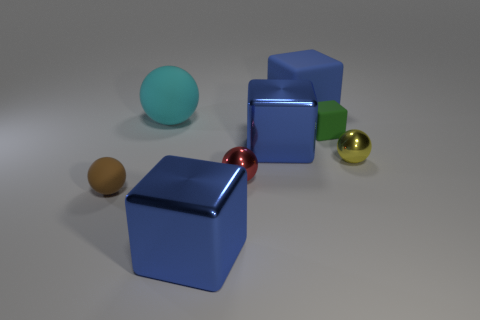How many objects are big things that are behind the tiny rubber sphere or brown spheres?
Offer a very short reply. 4. How many other objects are the same material as the green object?
Offer a terse response. 3. What size is the blue metal object behind the brown object?
Your response must be concise. Large. What shape is the small yellow thing that is the same material as the red thing?
Make the answer very short. Sphere. Does the yellow object have the same material as the big block behind the green thing?
Provide a succinct answer. No. There is a small rubber thing that is left of the big cyan ball; does it have the same shape as the cyan thing?
Provide a succinct answer. Yes. There is a cyan object that is the same shape as the yellow metallic object; what is it made of?
Keep it short and to the point. Rubber. There is a yellow object; is it the same shape as the small rubber object left of the cyan object?
Keep it short and to the point. Yes. What color is the rubber object that is both behind the yellow metallic ball and left of the blue rubber cube?
Give a very brief answer. Cyan. Are there any tiny cyan rubber cubes?
Give a very brief answer. No. 